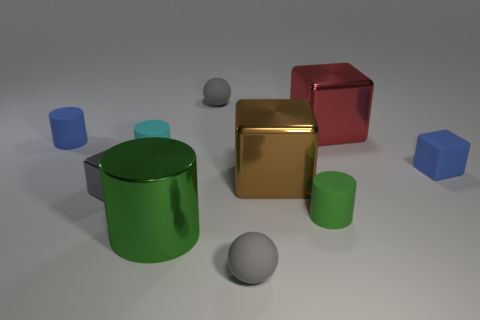The ball in front of the blue object that is behind the small blue block is what color?
Give a very brief answer. Gray. Is there a block of the same color as the large cylinder?
Provide a succinct answer. No. What is the size of the rubber sphere that is behind the gray ball in front of the small gray sphere that is behind the tiny gray metallic object?
Make the answer very short. Small. There is a tiny cyan thing; is it the same shape as the large thing that is in front of the tiny gray metallic object?
Your answer should be compact. Yes. How many other objects are the same size as the green matte cylinder?
Offer a very short reply. 6. There is a object that is behind the big red block; what size is it?
Keep it short and to the point. Small. How many big green things have the same material as the red cube?
Keep it short and to the point. 1. There is a shiny thing behind the small cyan thing; is its shape the same as the large brown thing?
Make the answer very short. Yes. There is a gray thing in front of the green rubber cylinder; what is its shape?
Offer a very short reply. Sphere. What size is the thing that is the same color as the large metallic cylinder?
Provide a short and direct response. Small. 